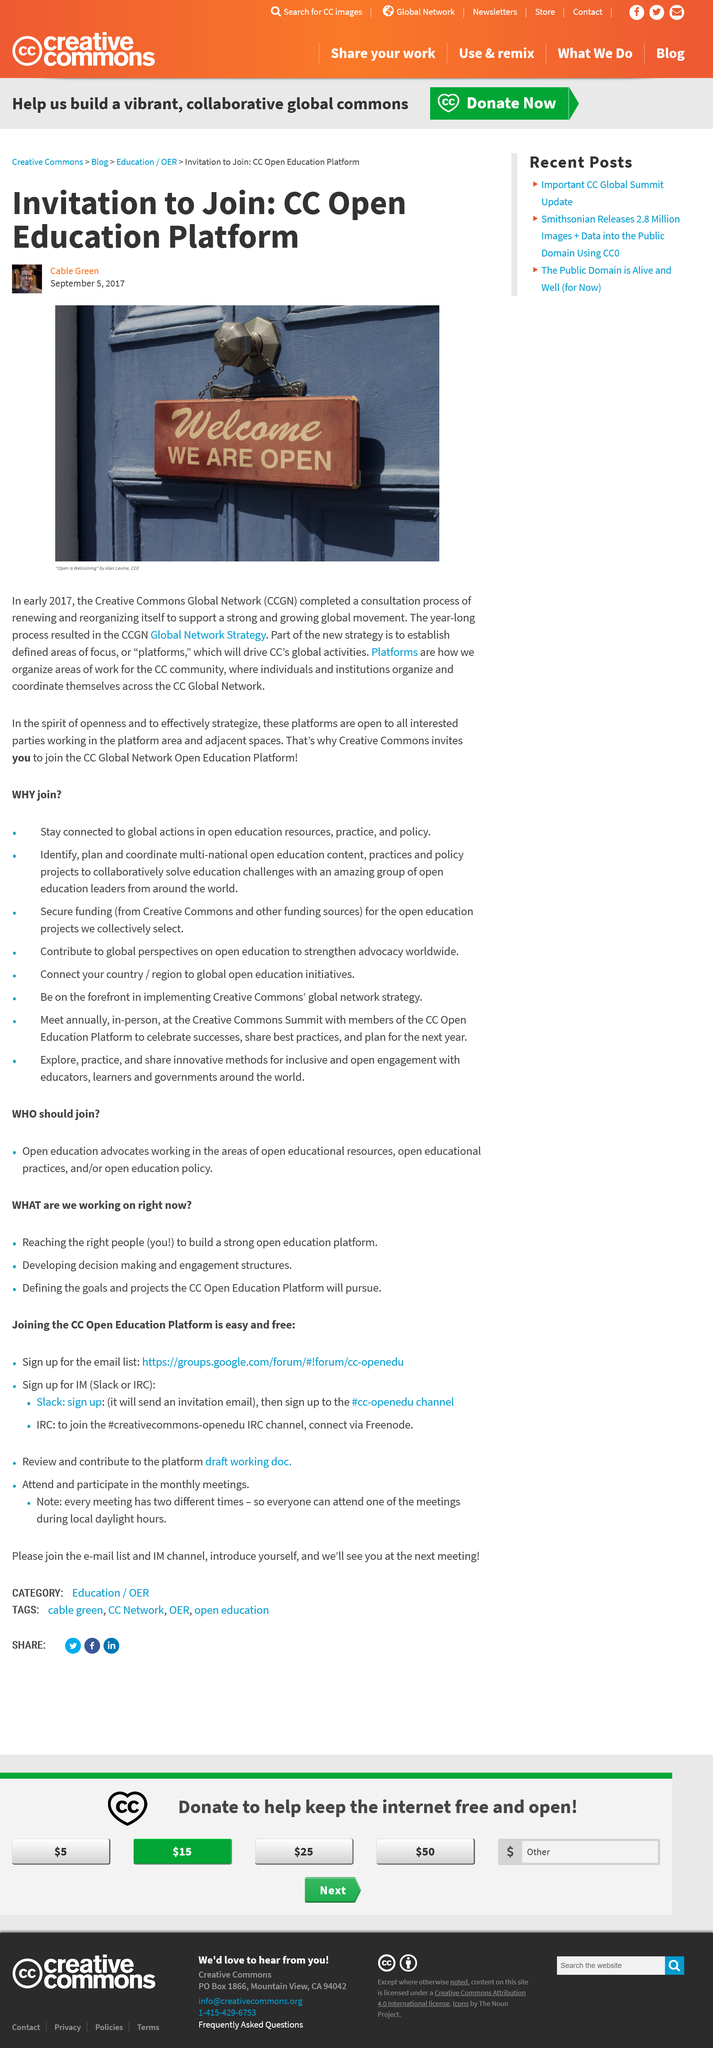List a handful of essential elements in this visual. As part of the new CC Strategy, establishing platforms will be a crucial component. The CCGN was renewed to continue promoting and strengthening the growing global movement for carbon capture, utilization and geological storage. The CC advertising is promoting a new Open Education Platform. 